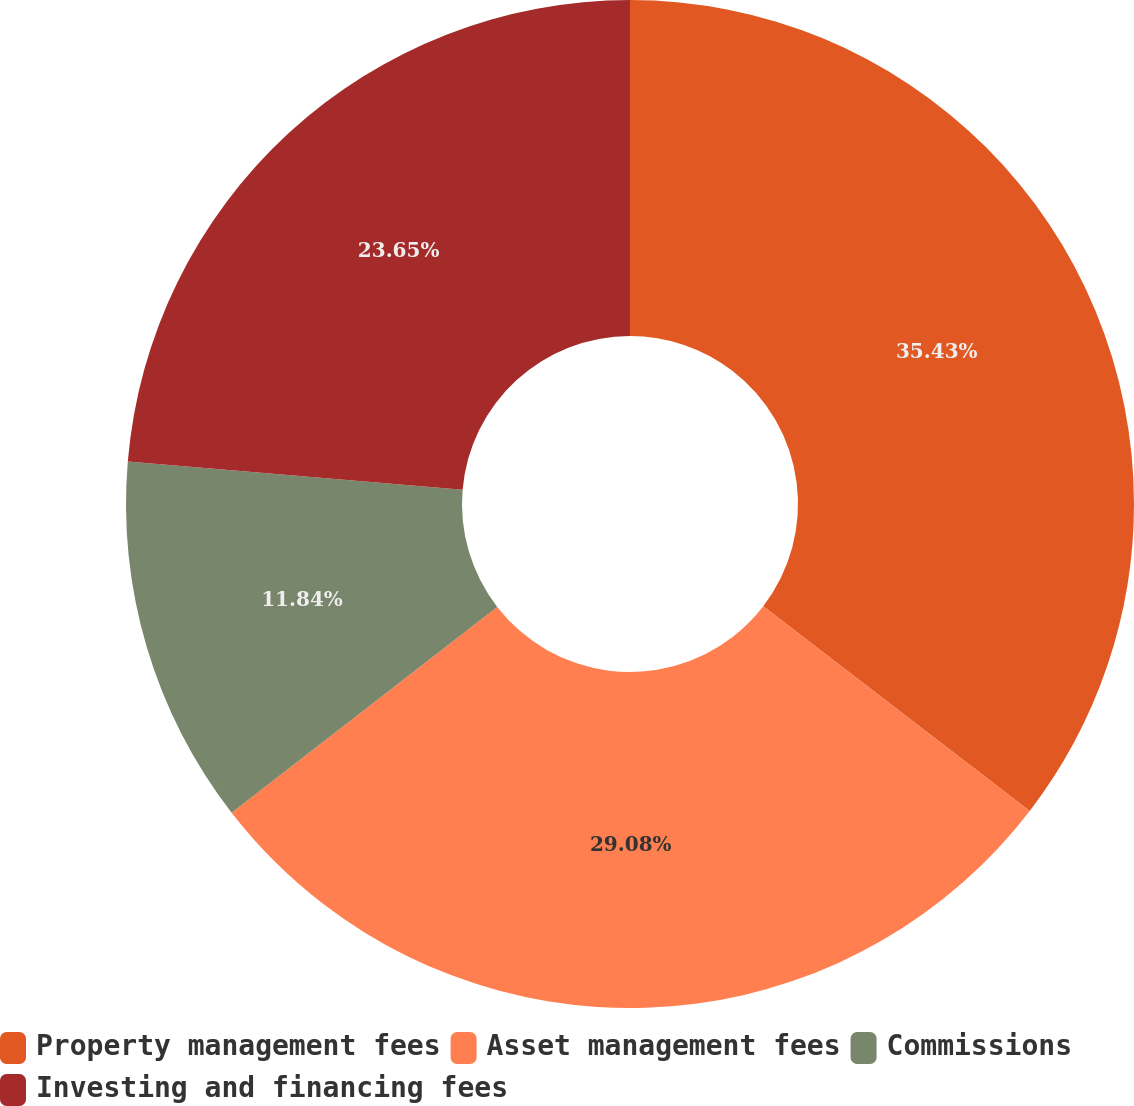Convert chart. <chart><loc_0><loc_0><loc_500><loc_500><pie_chart><fcel>Property management fees<fcel>Asset management fees<fcel>Commissions<fcel>Investing and financing fees<nl><fcel>35.42%<fcel>29.08%<fcel>11.84%<fcel>23.65%<nl></chart> 